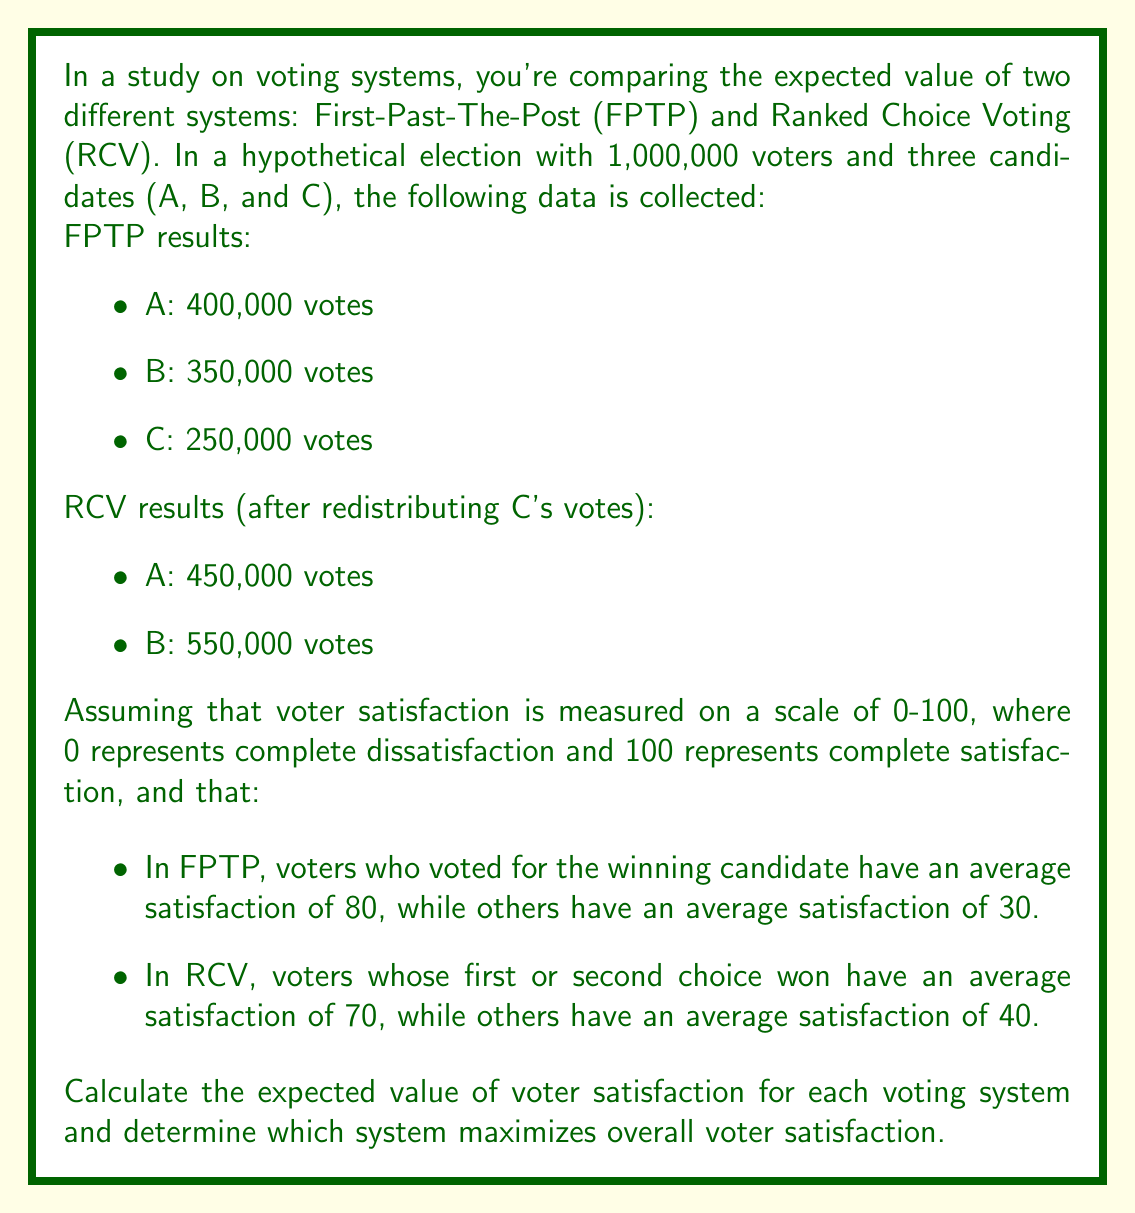Provide a solution to this math problem. To solve this problem, we need to calculate the expected value of voter satisfaction for each voting system and compare them. Let's break it down step by step:

1. First-Past-The-Post (FPTP) System:

In FPTP, candidate A wins with 400,000 votes.

Let $S_{FPTP}$ be the total satisfaction in FPTP:

$$S_{FPTP} = (400,000 \times 80) + (600,000 \times 30)$$
$$S_{FPTP} = 32,000,000 + 18,000,000 = 50,000,000$$

The expected value of voter satisfaction in FPTP is:

$$E_{FPTP} = \frac{S_{FPTP}}{1,000,000} = \frac{50,000,000}{1,000,000} = 50$$

2. Ranked Choice Voting (RCV) System:

In RCV, candidate B wins with 550,000 votes after redistribution.

To calculate the satisfaction, we need to consider that voters who chose B as their first or second choice are satisfied at 70, while others are at 40.

B's voters: 350,000 (first choice) + (550,000 - 350,000 = 200,000) (second choice) = 550,000
A and C's voters who didn't choose B as second: 1,000,000 - 550,000 = 450,000

Let $S_{RCV}$ be the total satisfaction in RCV:

$$S_{RCV} = (550,000 \times 70) + (450,000 \times 40)$$
$$S_{RCV} = 38,500,000 + 18,000,000 = 56,500,000$$

The expected value of voter satisfaction in RCV is:

$$E_{RCV} = \frac{S_{RCV}}{1,000,000} = \frac{56,500,000}{1,000,000} = 56.5$$

3. Comparing the two systems:

$E_{RCV} (56.5) > E_{FPTP} (50)$

Therefore, the Ranked Choice Voting system maximizes overall voter satisfaction in this scenario.
Answer: The expected value of voter satisfaction for FPTP is 50, and for RCV is 56.5. The Ranked Choice Voting (RCV) system maximizes overall voter satisfaction with a higher expected value of 56.5 compared to 50 for First-Past-The-Post (FPTP). 